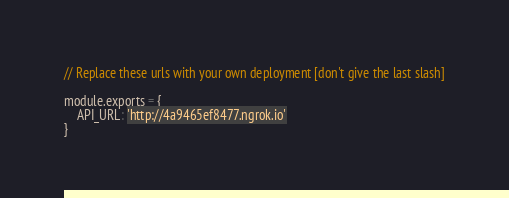<code> <loc_0><loc_0><loc_500><loc_500><_JavaScript_>// Replace these urls with your own deployment [don't give the last slash]

module.exports = {
    API_URL: 'http://4a9465ef8477.ngrok.io'
}
</code> 